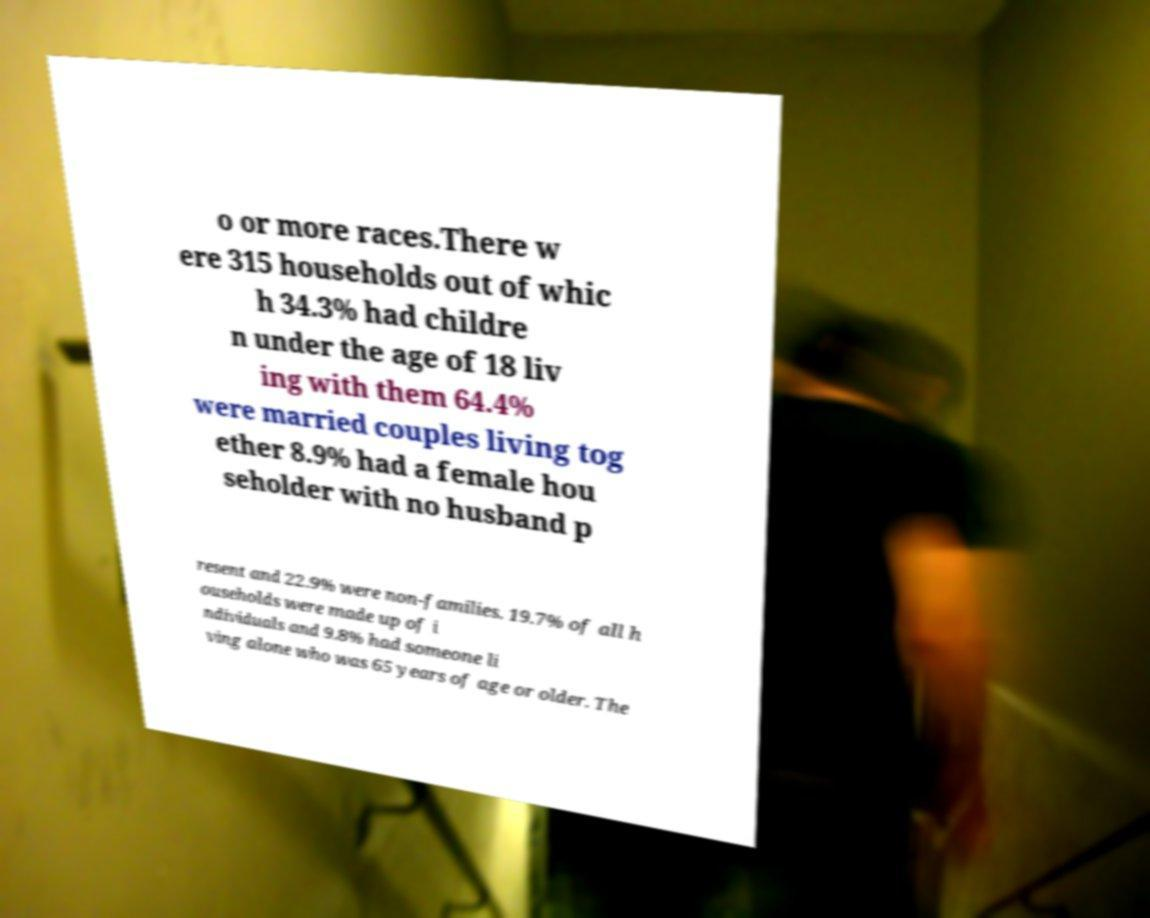Could you extract and type out the text from this image? o or more races.There w ere 315 households out of whic h 34.3% had childre n under the age of 18 liv ing with them 64.4% were married couples living tog ether 8.9% had a female hou seholder with no husband p resent and 22.9% were non-families. 19.7% of all h ouseholds were made up of i ndividuals and 9.8% had someone li ving alone who was 65 years of age or older. The 